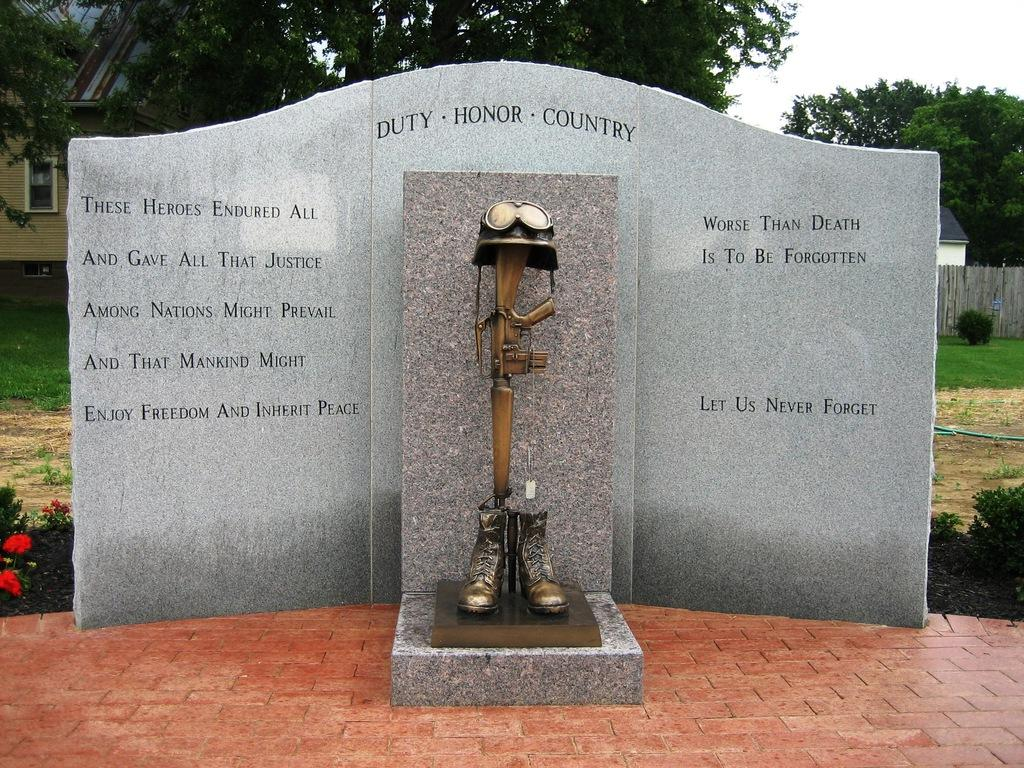What is written or depicted on the wall in the image? There is a wall with text in the image. What is placed in front of the wall? There are sculptures placed in front of the wall. What can be seen in the background of the image? Buildings, trees, the ground, shrubs, flowers, and the sky are visible in the background of the image. Can you see a railway in the image? There is no railway present in the image. What type of hand is holding the flowers in the image? There are no hands or people holding flowers in the image; only the flowers themselves are visible. 